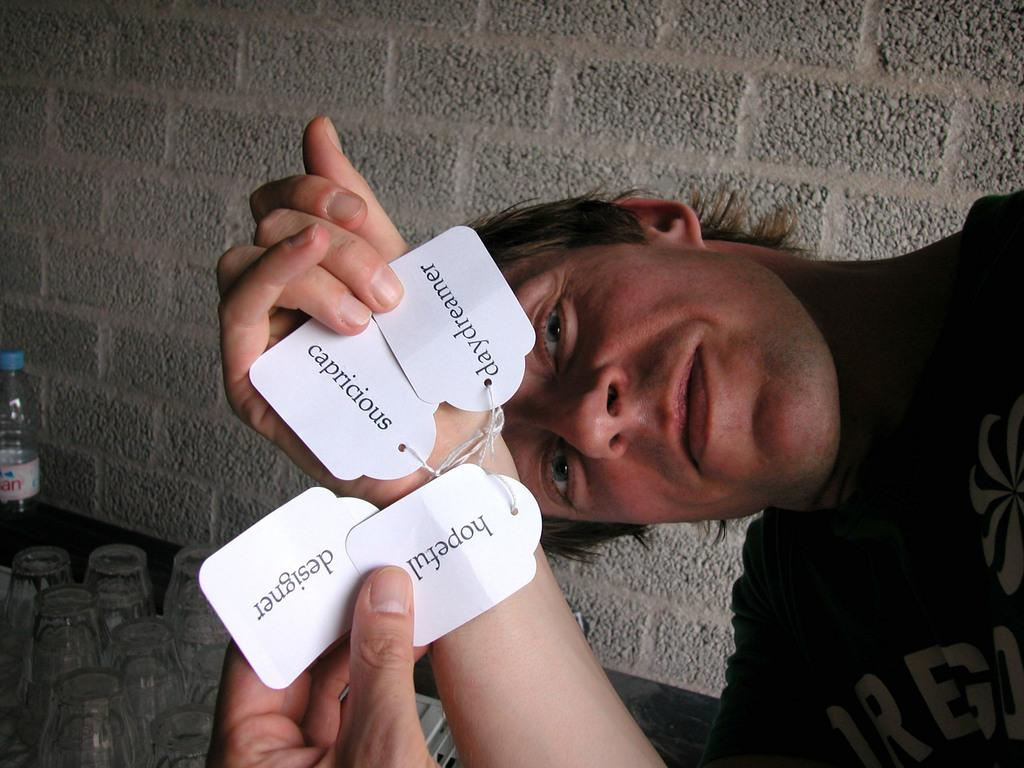Who is present in the image? There is a man in the image. Where is the man located in the image? The man is on the left side of the image. What is attached to the man's hand? The man has name tags tied to his hand. What is visible behind the man? There is a wall behind the man. What items can be seen on the table in the image? There are glasses and a water bottle on a table in the image. What type of owl can be seen perched on the water bottle in the image? There is no owl present in the image; it only features a man, name tags, a wall, glasses, and a water bottle on a table. 